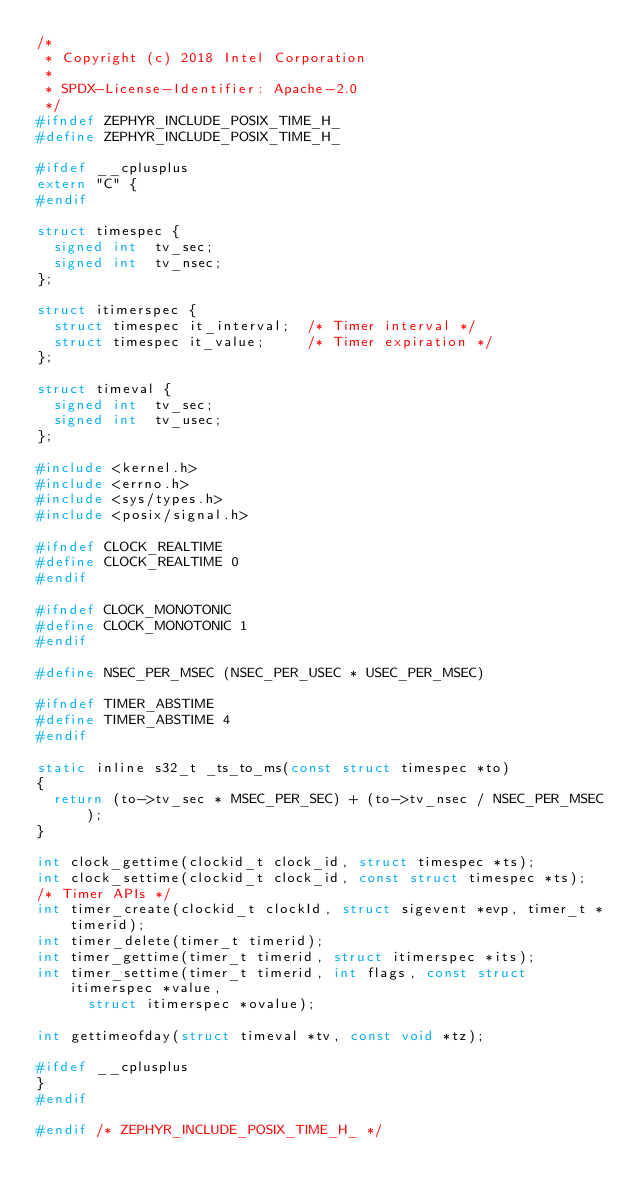<code> <loc_0><loc_0><loc_500><loc_500><_C_>/*
 * Copyright (c) 2018 Intel Corporation
 *
 * SPDX-License-Identifier: Apache-2.0
 */
#ifndef ZEPHYR_INCLUDE_POSIX_TIME_H_
#define ZEPHYR_INCLUDE_POSIX_TIME_H_

#ifdef __cplusplus
extern "C" {
#endif

struct timespec {
	signed int  tv_sec;
	signed int  tv_nsec;
};

struct itimerspec {
	struct timespec it_interval;  /* Timer interval */
	struct timespec it_value;     /* Timer expiration */
};

struct timeval {
	signed int  tv_sec;
	signed int  tv_usec;
};

#include <kernel.h>
#include <errno.h>
#include <sys/types.h>
#include <posix/signal.h>

#ifndef CLOCK_REALTIME
#define CLOCK_REALTIME 0
#endif

#ifndef CLOCK_MONOTONIC
#define CLOCK_MONOTONIC 1
#endif

#define NSEC_PER_MSEC (NSEC_PER_USEC * USEC_PER_MSEC)

#ifndef TIMER_ABSTIME
#define TIMER_ABSTIME 4
#endif

static inline s32_t _ts_to_ms(const struct timespec *to)
{
	return (to->tv_sec * MSEC_PER_SEC) + (to->tv_nsec / NSEC_PER_MSEC);
}

int clock_gettime(clockid_t clock_id, struct timespec *ts);
int clock_settime(clockid_t clock_id, const struct timespec *ts);
/* Timer APIs */
int timer_create(clockid_t clockId, struct sigevent *evp, timer_t *timerid);
int timer_delete(timer_t timerid);
int timer_gettime(timer_t timerid, struct itimerspec *its);
int timer_settime(timer_t timerid, int flags, const struct itimerspec *value,
		  struct itimerspec *ovalue);

int gettimeofday(struct timeval *tv, const void *tz);

#ifdef __cplusplus
}
#endif

#endif /* ZEPHYR_INCLUDE_POSIX_TIME_H_ */
</code> 